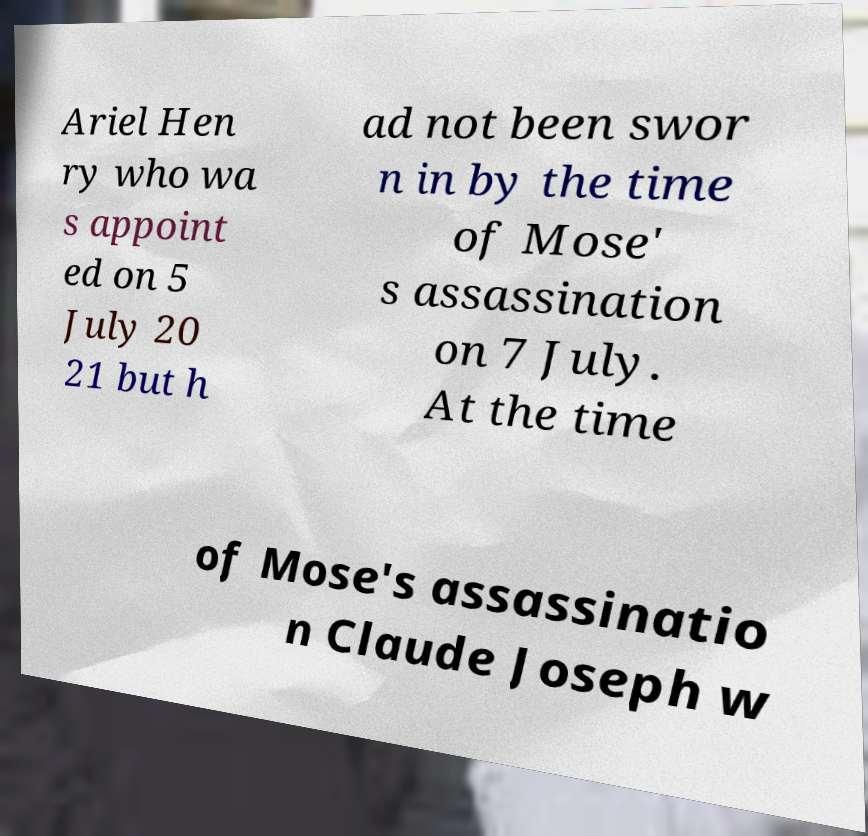For documentation purposes, I need the text within this image transcribed. Could you provide that? Ariel Hen ry who wa s appoint ed on 5 July 20 21 but h ad not been swor n in by the time of Mose' s assassination on 7 July. At the time of Mose's assassinatio n Claude Joseph w 